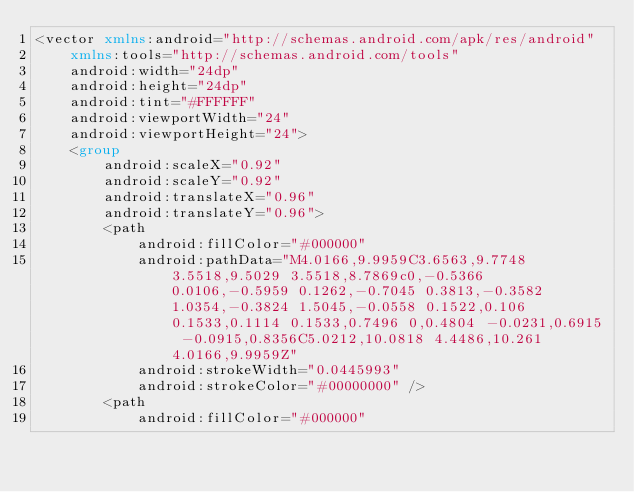<code> <loc_0><loc_0><loc_500><loc_500><_XML_><vector xmlns:android="http://schemas.android.com/apk/res/android"
    xmlns:tools="http://schemas.android.com/tools"
    android:width="24dp"
    android:height="24dp"
    android:tint="#FFFFFF"
    android:viewportWidth="24"
    android:viewportHeight="24">
    <group
        android:scaleX="0.92"
        android:scaleY="0.92"
        android:translateX="0.96"
        android:translateY="0.96">
        <path
            android:fillColor="#000000"
            android:pathData="M4.0166,9.9959C3.6563,9.7748 3.5518,9.5029 3.5518,8.7869c0,-0.5366 0.0106,-0.5959 0.1262,-0.7045 0.3813,-0.3582 1.0354,-0.3824 1.5045,-0.0558 0.1522,0.106 0.1533,0.1114 0.1533,0.7496 0,0.4804 -0.0231,0.6915 -0.0915,0.8356C5.0212,10.0818 4.4486,10.261 4.0166,9.9959Z"
            android:strokeWidth="0.0445993"
            android:strokeColor="#00000000" />
        <path
            android:fillColor="#000000"</code> 